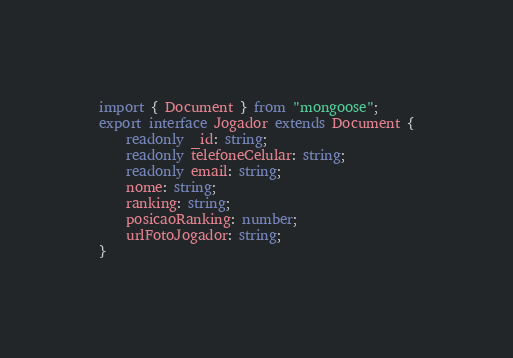Convert code to text. <code><loc_0><loc_0><loc_500><loc_500><_TypeScript_>import { Document } from "mongoose";
export interface Jogador extends Document {
    readonly _id: string;
    readonly telefoneCelular: string;
    readonly email: string;
    nome: string;
    ranking: string;
    posicaoRanking: number;
    urlFotoJogador: string;
}</code> 